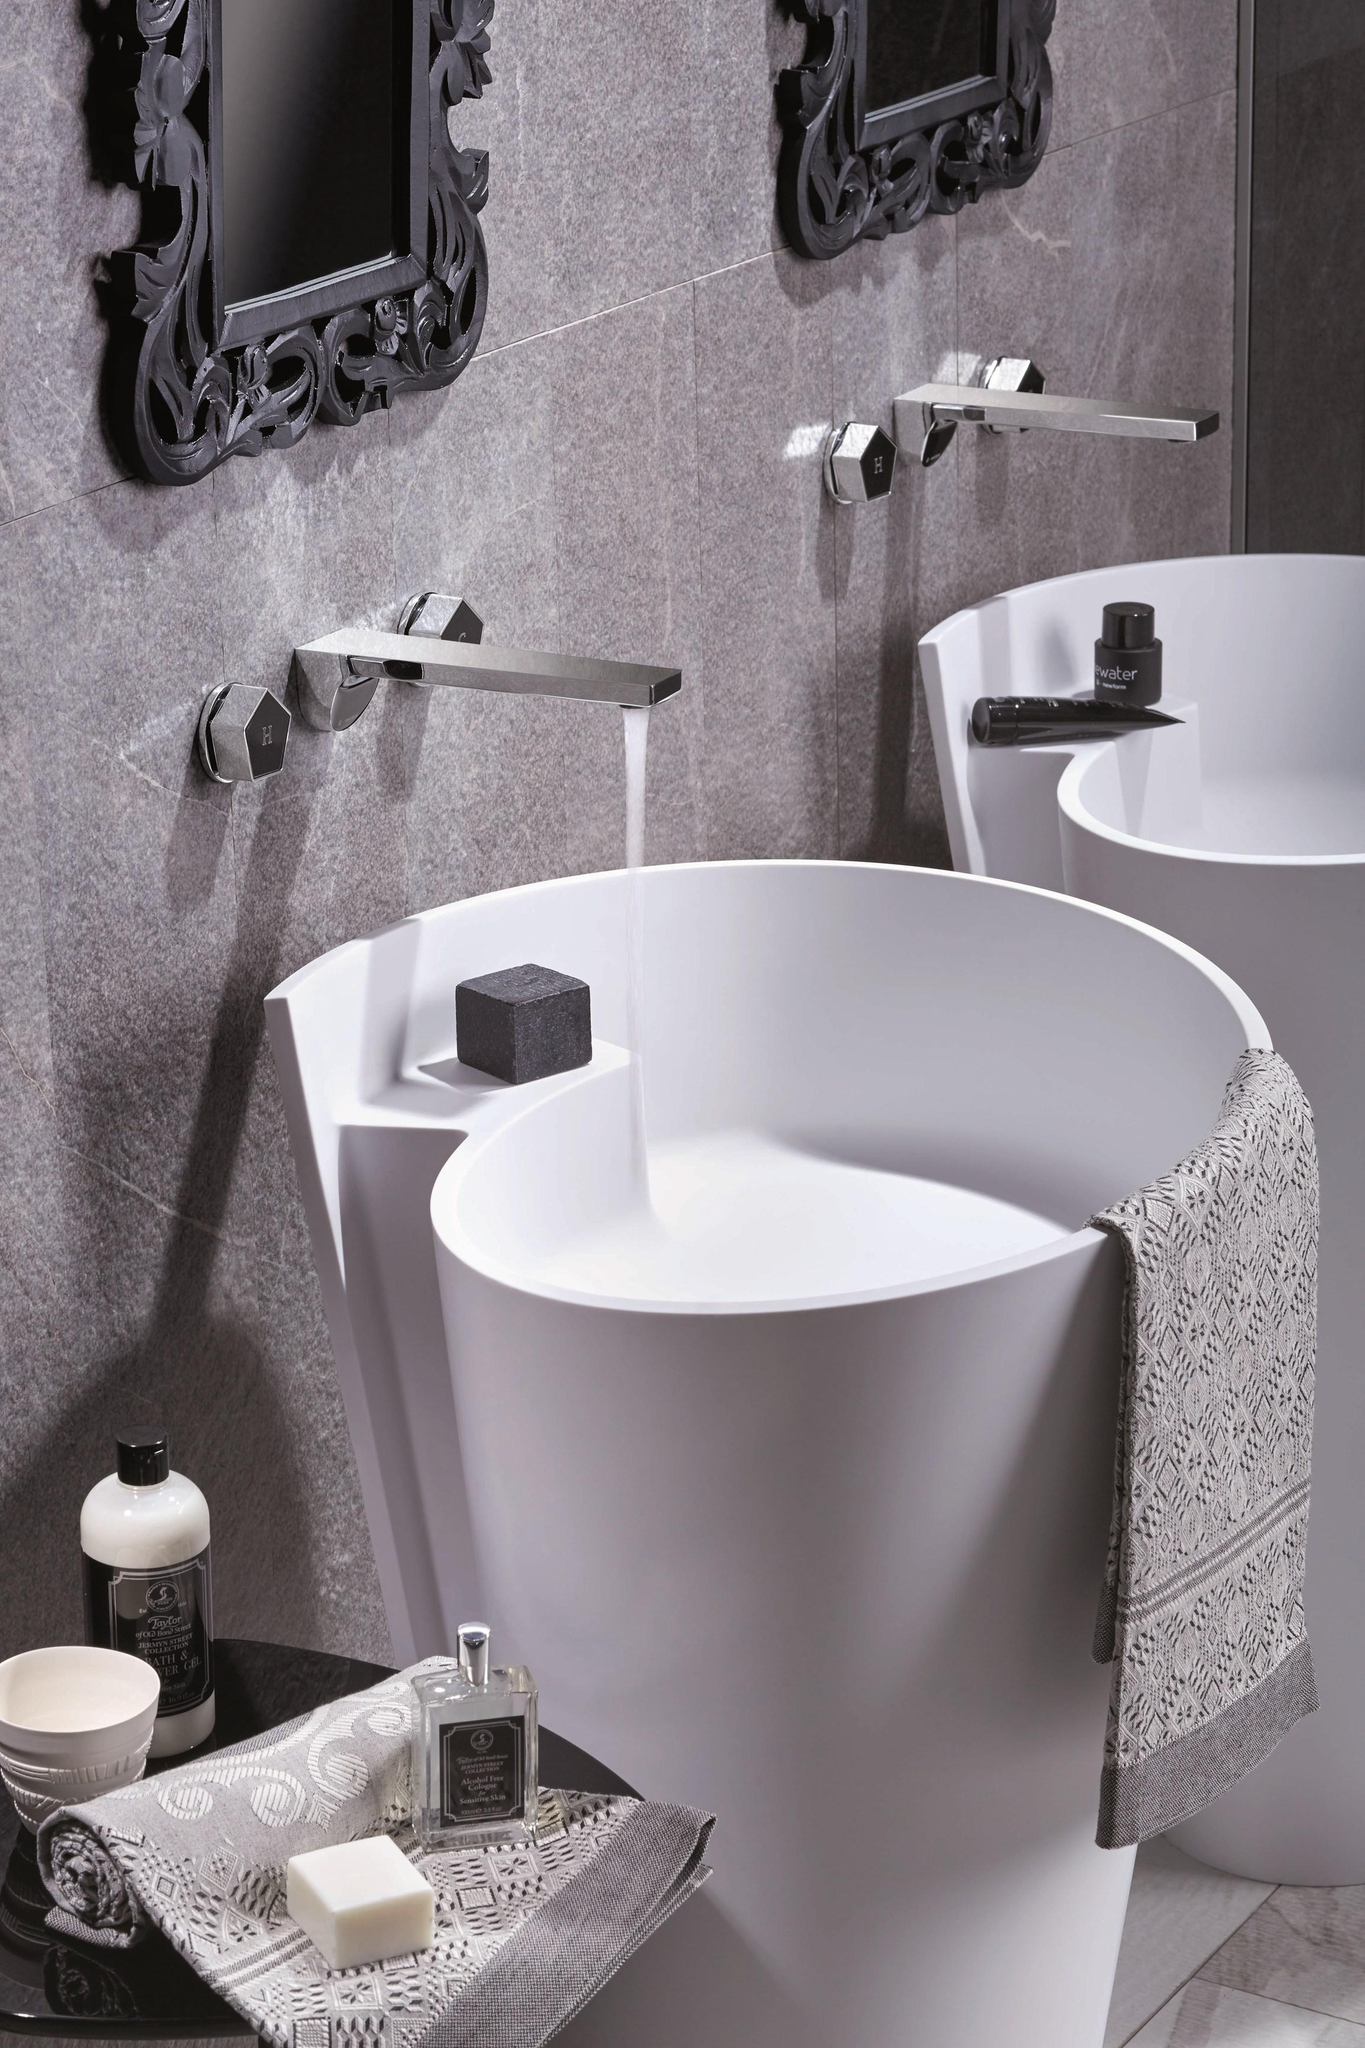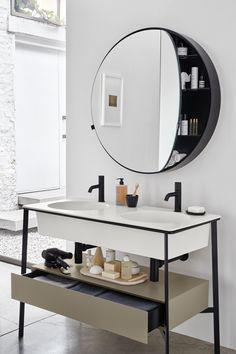The first image is the image on the left, the second image is the image on the right. Analyze the images presented: Is the assertion "There is a silver colored sink, and a not-silver colored sink." valid? Answer yes or no. No. The first image is the image on the left, the second image is the image on the right. Evaluate the accuracy of this statement regarding the images: "At least part of a round mirror is visible above a rectangular vanity.". Is it true? Answer yes or no. Yes. 